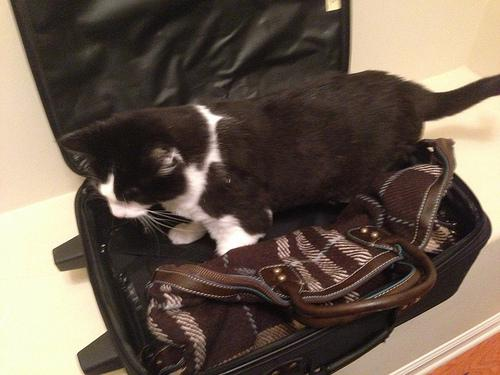Question: what animal is in the suitcase?
Choices:
A. A rat.
B. An armadillo.
C. A lemur.
D. Cat.
Answer with the letter. Answer: D Question: who is in the picture?
Choices:
A. A scary clown.
B. The referee.
C. No one.
D. The gigantic woman.
Answer with the letter. Answer: C Question: what color is the bag?
Choices:
A. Brown.
B. Yellow.
C. Black.
D. White.
Answer with the letter. Answer: A Question: what nonliving thing is in the suitcase?
Choices:
A. Clothes.
B. A razor.
C. A bag.
D. A toothbrush.
Answer with the letter. Answer: C Question: where is the cat?
Choices:
A. In the litter box.
B. Outside.
C. In a suitcase.
D. Downstairs.
Answer with the letter. Answer: C 